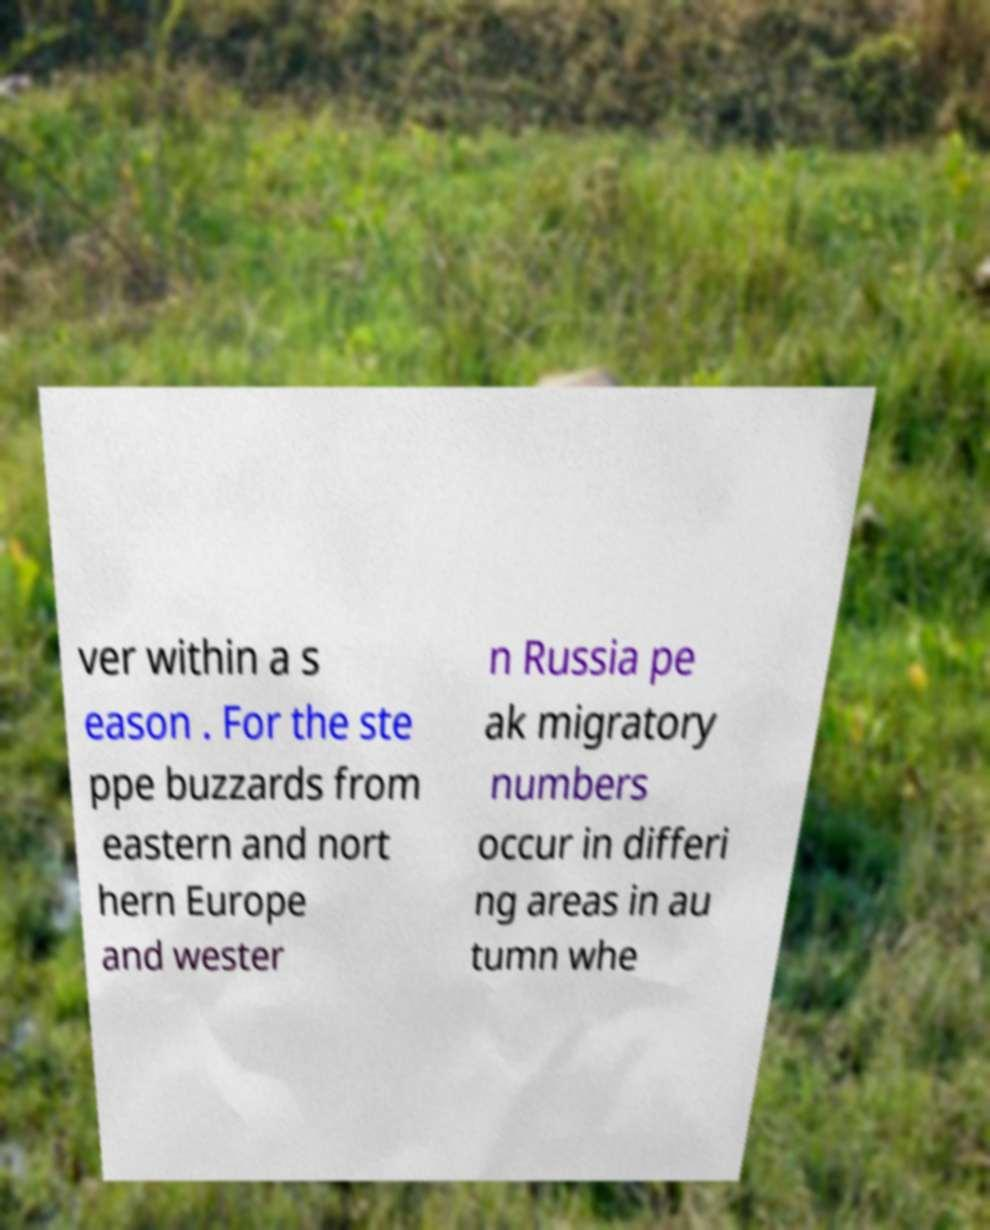I need the written content from this picture converted into text. Can you do that? ver within a s eason . For the ste ppe buzzards from eastern and nort hern Europe and wester n Russia pe ak migratory numbers occur in differi ng areas in au tumn whe 